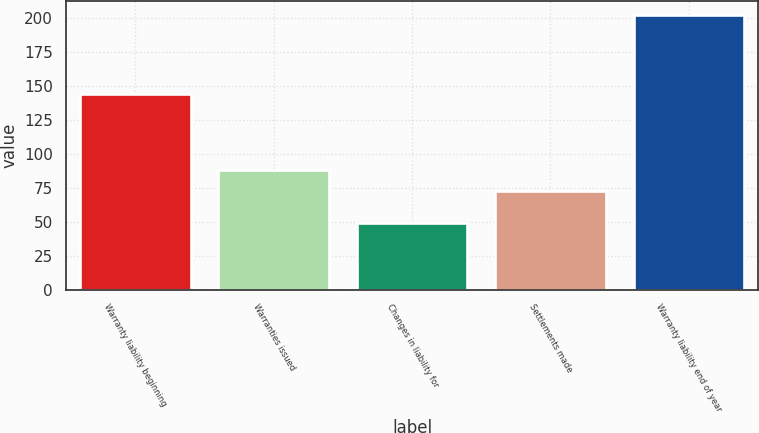Convert chart. <chart><loc_0><loc_0><loc_500><loc_500><bar_chart><fcel>Warranty liability beginning<fcel>Warranties issued<fcel>Changes in liability for<fcel>Settlements made<fcel>Warranty liability end of year<nl><fcel>143.7<fcel>87.87<fcel>49.3<fcel>72.6<fcel>202<nl></chart> 